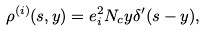<formula> <loc_0><loc_0><loc_500><loc_500>\rho ^ { ( i ) } ( s , y ) = e _ { i } ^ { 2 } N _ { c } y \delta ^ { \prime } ( s - y ) ,</formula> 